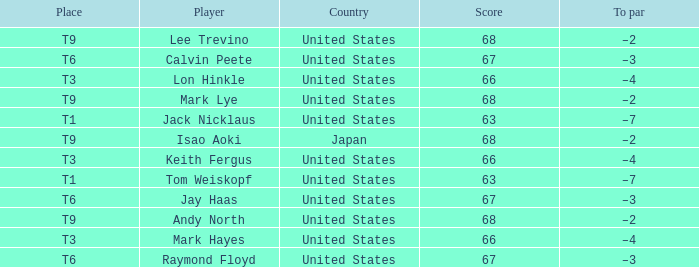What is To Par, when Place is "T9", and when Player is "Lee Trevino"? –2. 